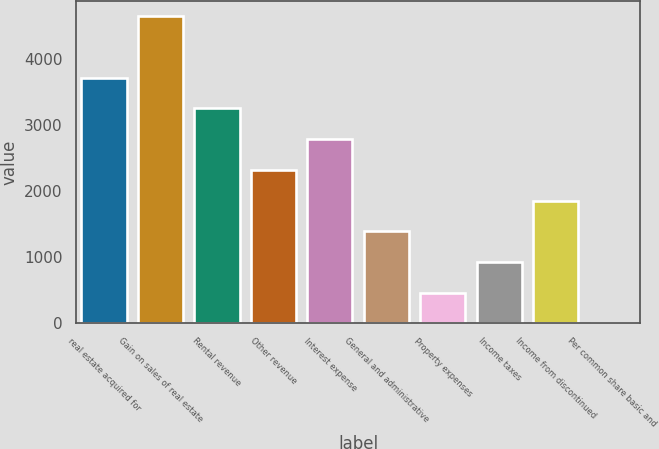Convert chart to OTSL. <chart><loc_0><loc_0><loc_500><loc_500><bar_chart><fcel>real estate acquired for<fcel>Gain on sales of real estate<fcel>Rental revenue<fcel>Other revenue<fcel>Interest expense<fcel>General and administrative<fcel>Property expenses<fcel>Income taxes<fcel>Income from discontinued<fcel>Per common share basic and<nl><fcel>3713.61<fcel>4642<fcel>3249.41<fcel>2321.01<fcel>2785.21<fcel>1392.61<fcel>464.21<fcel>928.41<fcel>1856.81<fcel>0.01<nl></chart> 